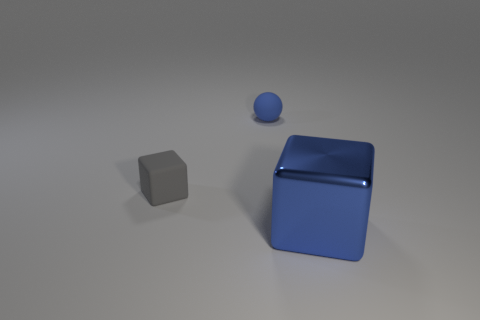What is the size of the blue thing that is behind the blue object in front of the cube that is to the left of the shiny thing?
Your answer should be very brief. Small. Are the tiny block and the blue thing that is to the left of the blue cube made of the same material?
Keep it short and to the point. Yes. Does the large metal object have the same shape as the tiny blue thing?
Keep it short and to the point. No. How many other things are there of the same material as the blue block?
Offer a very short reply. 0. What number of big blue things have the same shape as the gray thing?
Ensure brevity in your answer.  1. What is the color of the thing that is both to the right of the tiny block and in front of the tiny blue rubber sphere?
Provide a succinct answer. Blue. What number of tiny gray rubber blocks are there?
Ensure brevity in your answer.  1. Does the blue rubber ball have the same size as the gray matte object?
Your response must be concise. Yes. Are there any big metal cylinders of the same color as the tiny rubber sphere?
Ensure brevity in your answer.  No. There is a blue thing that is in front of the tiny rubber sphere; is its shape the same as the gray matte object?
Your answer should be compact. Yes. 